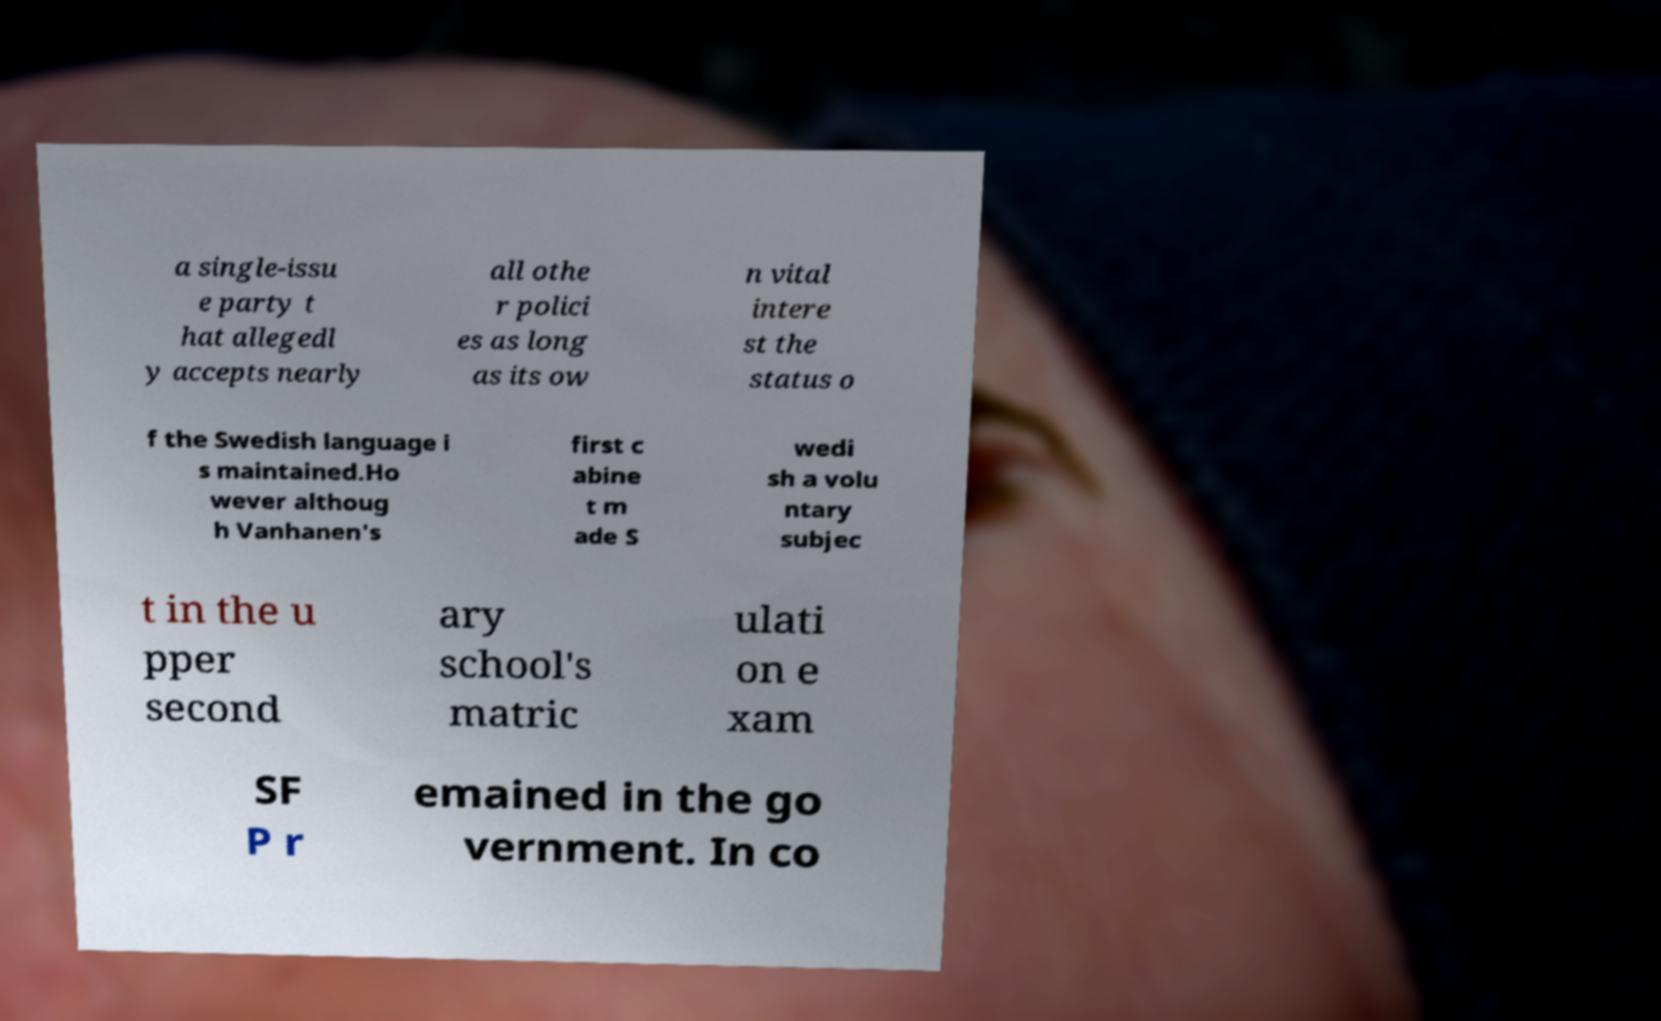Can you read and provide the text displayed in the image?This photo seems to have some interesting text. Can you extract and type it out for me? a single-issu e party t hat allegedl y accepts nearly all othe r polici es as long as its ow n vital intere st the status o f the Swedish language i s maintained.Ho wever althoug h Vanhanen's first c abine t m ade S wedi sh a volu ntary subjec t in the u pper second ary school's matric ulati on e xam SF P r emained in the go vernment. In co 